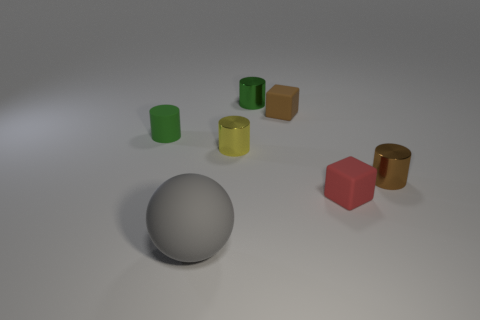The other cylinder that is the same color as the rubber cylinder is what size?
Ensure brevity in your answer.  Small. There is a yellow shiny cylinder; is it the same size as the matte thing in front of the small red matte thing?
Provide a short and direct response. No. What number of cylinders are tiny purple things or green metal objects?
Make the answer very short. 1. What is the size of the brown block that is the same material as the big gray sphere?
Give a very brief answer. Small. There is a green matte object that is left of the large matte thing; is its size the same as the green cylinder that is on the right side of the tiny yellow shiny object?
Your response must be concise. Yes. How many things are brown matte objects or small red matte cubes?
Ensure brevity in your answer.  2. There is a big gray thing; what shape is it?
Offer a terse response. Sphere. What size is the yellow metallic object that is the same shape as the tiny green rubber thing?
Provide a succinct answer. Small. Are there any other things that have the same material as the tiny brown block?
Keep it short and to the point. Yes. What size is the shiny object that is left of the green cylinder on the right side of the large object?
Offer a terse response. Small. 